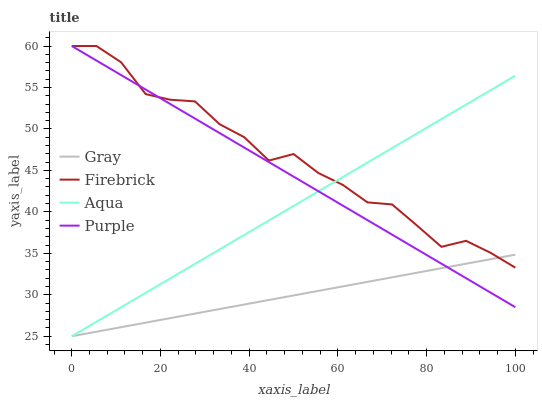Does Gray have the minimum area under the curve?
Answer yes or no. Yes. Does Firebrick have the maximum area under the curve?
Answer yes or no. Yes. Does Firebrick have the minimum area under the curve?
Answer yes or no. No. Does Gray have the maximum area under the curve?
Answer yes or no. No. Is Purple the smoothest?
Answer yes or no. Yes. Is Firebrick the roughest?
Answer yes or no. Yes. Is Gray the smoothest?
Answer yes or no. No. Is Gray the roughest?
Answer yes or no. No. Does Gray have the lowest value?
Answer yes or no. Yes. Does Firebrick have the lowest value?
Answer yes or no. No. Does Firebrick have the highest value?
Answer yes or no. Yes. Does Gray have the highest value?
Answer yes or no. No. Does Gray intersect Aqua?
Answer yes or no. Yes. Is Gray less than Aqua?
Answer yes or no. No. Is Gray greater than Aqua?
Answer yes or no. No. 